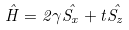Convert formula to latex. <formula><loc_0><loc_0><loc_500><loc_500>\hat { H } = 2 \gamma \hat { S _ { x } } + t \hat { S _ { z } }</formula> 